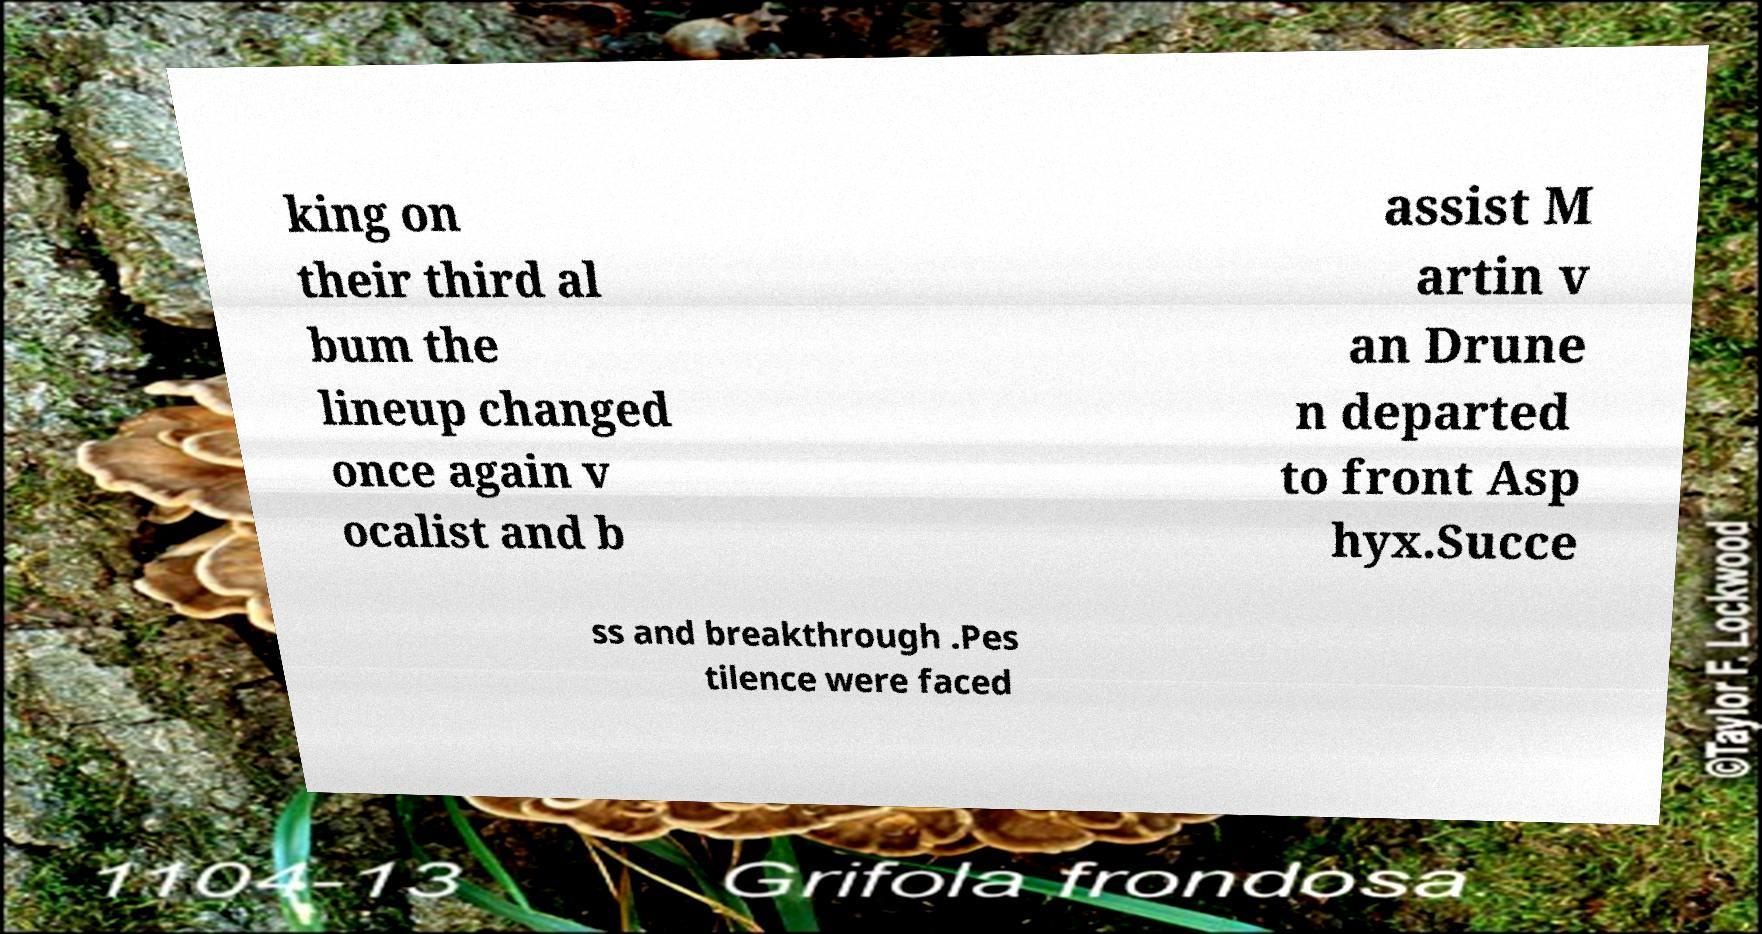What messages or text are displayed in this image? I need them in a readable, typed format. king on their third al bum the lineup changed once again v ocalist and b assist M artin v an Drune n departed to front Asp hyx.Succe ss and breakthrough .Pes tilence were faced 